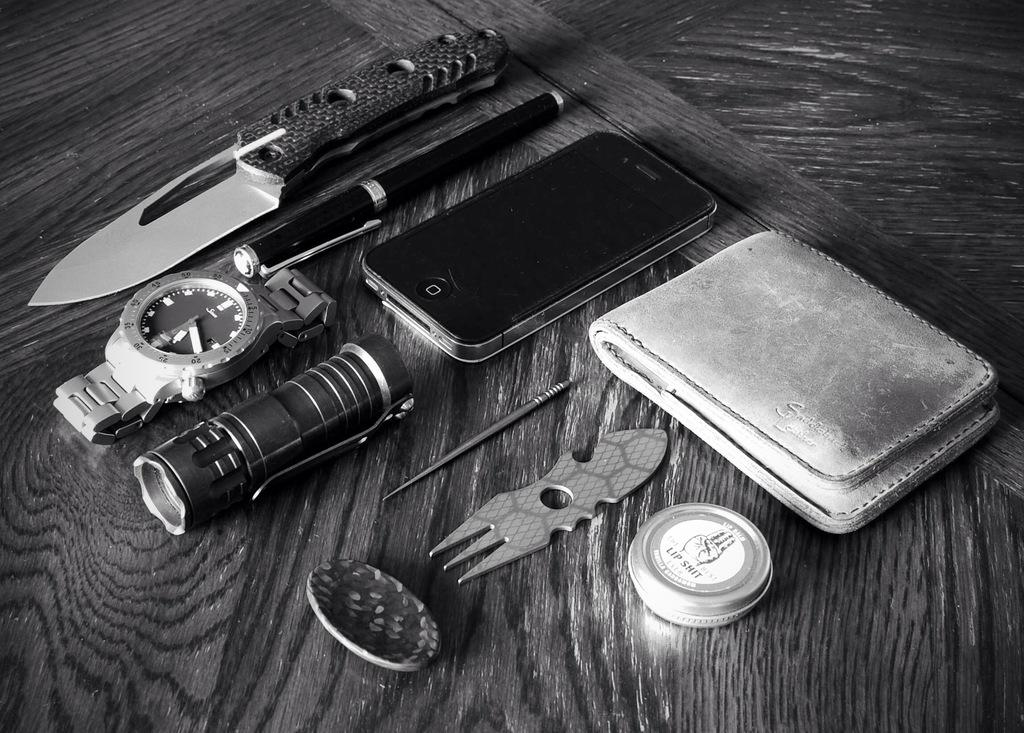What objects can be seen in the image? There is a knife, a pen, a watch, a mobile, and a wallet in the image. What type of accessory is present in the image? There are accessories in the image. What is the color scheme of the image? The image is black and white. How many kitties are playing with the pen in the image? There are no kitties present in the image. What type of animal can be seen interacting with the wallet in the image? There are no animals interacting with the wallet in the image. 